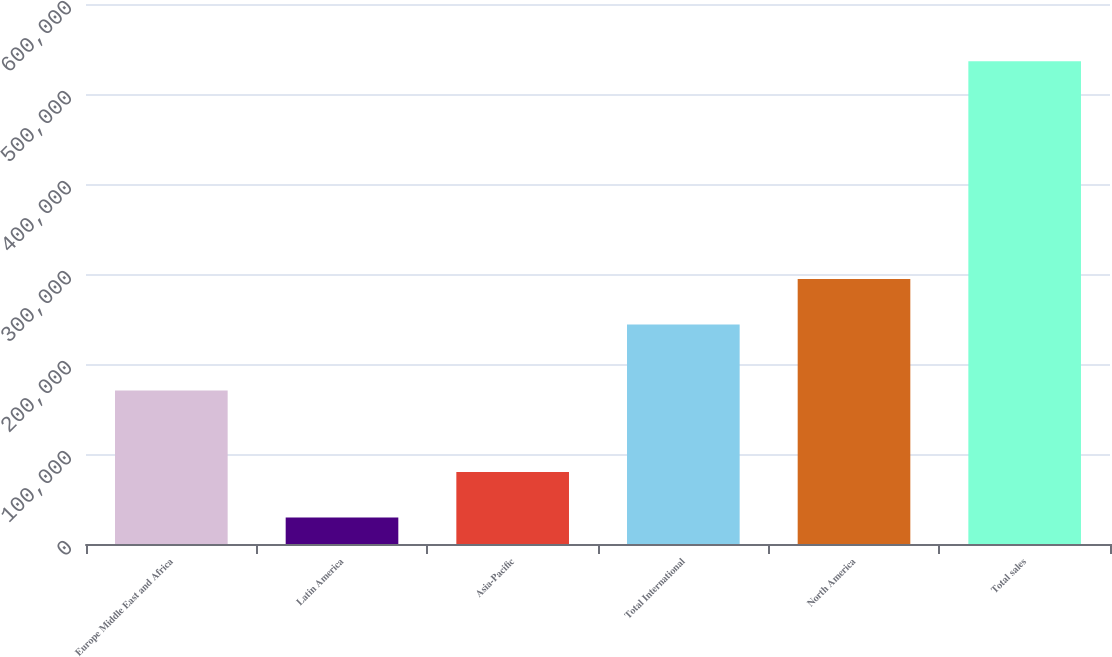Convert chart to OTSL. <chart><loc_0><loc_0><loc_500><loc_500><bar_chart><fcel>Europe Middle East and Africa<fcel>Latin America<fcel>Asia-Pacific<fcel>Total International<fcel>North America<fcel>Total sales<nl><fcel>170544<fcel>29406<fcel>80105.1<fcel>243854<fcel>294553<fcel>536397<nl></chart> 